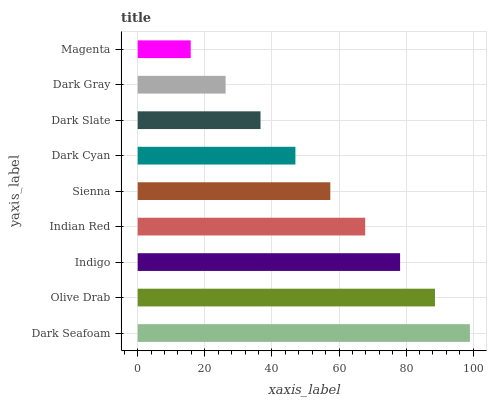Is Magenta the minimum?
Answer yes or no. Yes. Is Dark Seafoam the maximum?
Answer yes or no. Yes. Is Olive Drab the minimum?
Answer yes or no. No. Is Olive Drab the maximum?
Answer yes or no. No. Is Dark Seafoam greater than Olive Drab?
Answer yes or no. Yes. Is Olive Drab less than Dark Seafoam?
Answer yes or no. Yes. Is Olive Drab greater than Dark Seafoam?
Answer yes or no. No. Is Dark Seafoam less than Olive Drab?
Answer yes or no. No. Is Sienna the high median?
Answer yes or no. Yes. Is Sienna the low median?
Answer yes or no. Yes. Is Dark Slate the high median?
Answer yes or no. No. Is Dark Gray the low median?
Answer yes or no. No. 